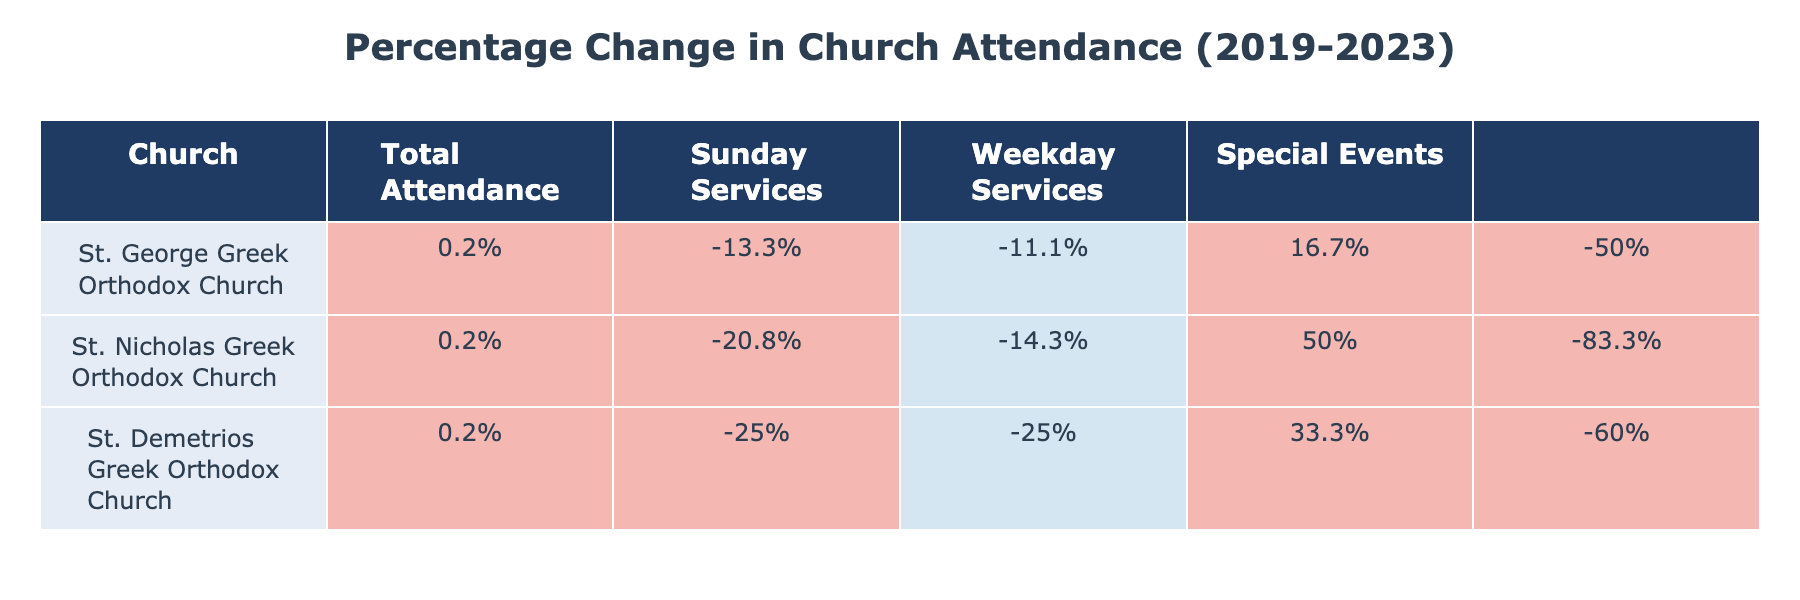What was the total attendance at St. George Greek Orthodox Church in 2023? The total attendance in 2023 for St. George Greek Orthodox Church is listed in the table as 1300.
Answer: 1300 Which church had the highest percentage increase in total attendance from 2019 to 2023? To find the highest percentage increase, I compare the percentage changes for each church: St. George increased by 33.3%, St. Nicholas decreased by 20.8%, and St. Demetrios decreased by 25%. The highest increase is from St. George Greek Orthodox Church.
Answer: St. George Greek Orthodox Church What is the total attendance at St. Nicholas Greek Orthodox Church in 2019 and in 2023 combined? The total attendance for St. Nicholas in 2019 is 1200, and in 2023 it is 950. Adding these together gives 1200 + 950 = 2150.
Answer: 2150 Did St. Demetrios Greek Orthodox Church see an increase or decrease in Sunday Services attendance from 2019 to 2023? In 2019, the Sunday Services attendance at St. Demetrios was 150, and in 2023 it is 200. This is an increase of 33.3%.
Answer: Yes What is the difference in special events attendance at St. George Greek Orthodox Church between 2022 and 2023? The special events attendance for St. George in 2022 is 150 and in 2023 is also 150. The difference is 150 - 150 = 0, meaning no change.
Answer: 0 Which church had the lowest total attendance in 2020 and what was the figure? The table shows that St. Demetrios had the lowest total attendance in 2020 at 400.
Answer: St. Demetrios; 400 What was the average Sunday Services attendance across all three churches in 2022? For 2022, St. George had 650, St. Nicholas had 500, and St. Demetrios had 400. Calculating the average: (650 + 500 + 400) / 3 = 550.
Answer: 550 Was the total attendance at St. Nicholas Greek Orthodox Church in 2021 higher than in 2020? The total attendance in 2020 was 600, and in 2021 it was 700. Since 700 > 600, this indicates a rise.
Answer: Yes What was the percentage change in weekday services attendance for St. Nicholas Greek Orthodox Church from 2019 to 2023? In 2019, St. Nicholas had 200 in weekday services attendance, and in 2023 it was 300. The percentage change is ((300 - 200) / 200) * 100 = 50%.
Answer: 50% 